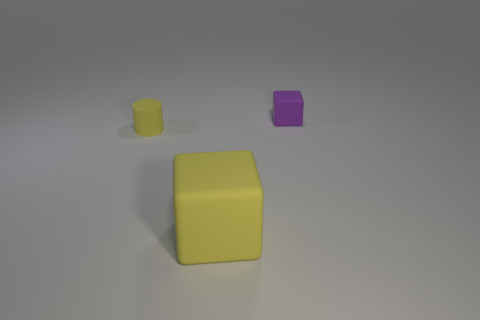Add 3 small yellow rubber objects. How many objects exist? 6 Subtract all cubes. How many objects are left? 1 Add 1 matte balls. How many matte balls exist? 1 Subtract 0 brown cylinders. How many objects are left? 3 Subtract all small yellow cylinders. Subtract all blue matte things. How many objects are left? 2 Add 1 large yellow rubber cubes. How many large yellow rubber cubes are left? 2 